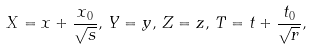<formula> <loc_0><loc_0><loc_500><loc_500>X = x + \frac { x _ { 0 } } { \sqrt { s } } , \, Y = y , \, Z = z , \, T = t + \frac { t _ { 0 } } { \sqrt { r } } ,</formula> 